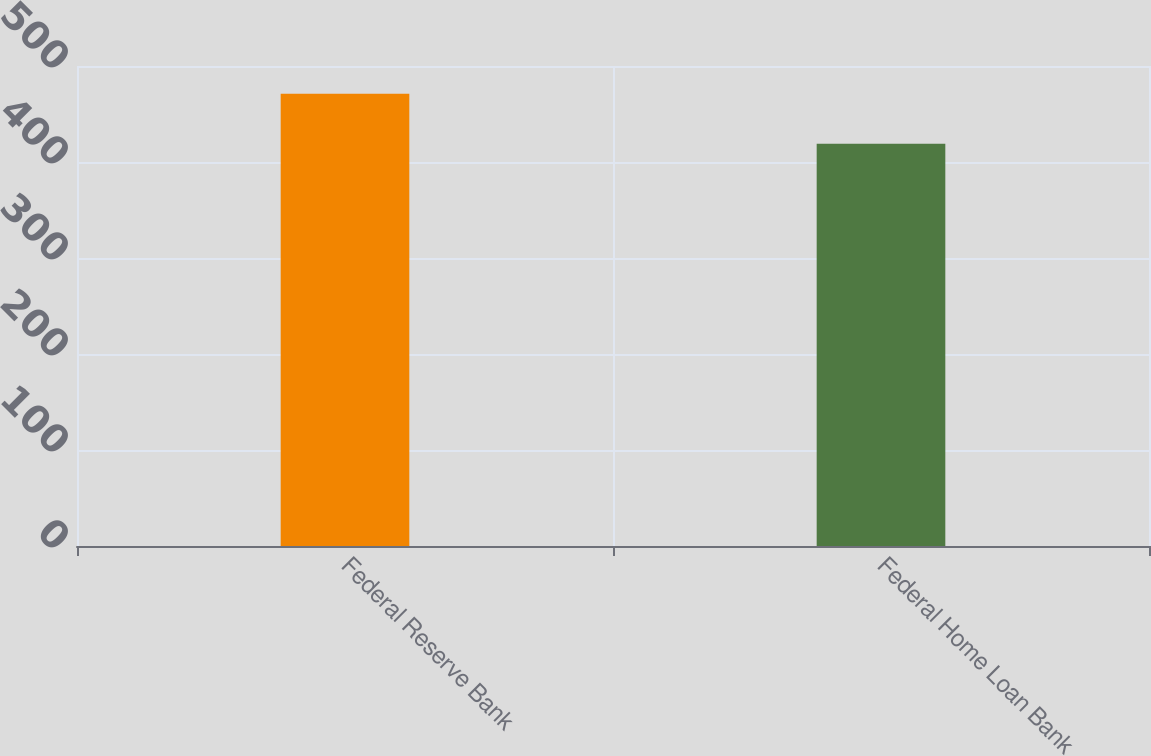<chart> <loc_0><loc_0><loc_500><loc_500><bar_chart><fcel>Federal Reserve Bank<fcel>Federal Home Loan Bank<nl><fcel>471<fcel>419<nl></chart> 